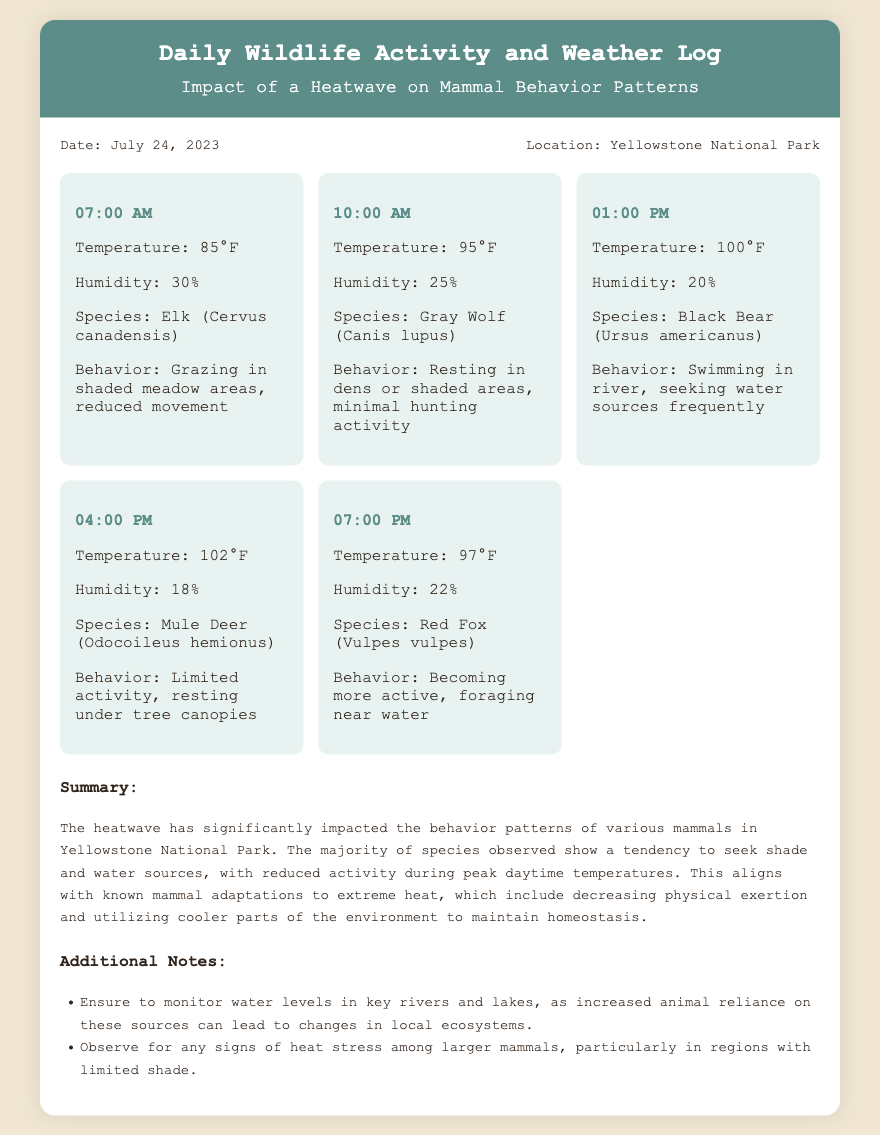what is the date of the log? The date is mentioned in the info section of the document as July 24, 2023.
Answer: July 24, 2023 what is the location of the observations? The location is stated in the info section as Yellowstone National Park.
Answer: Yellowstone National Park what species was observed at 01:00 PM? The species observed at that time is detailed in the observations section of the document as Black Bear.
Answer: Black Bear what behavior did the Gray Wolf exhibit at 10:00 AM? The behavior is described in the observations as resting in dens or shaded areas, minimal hunting activity.
Answer: Resting in dens or shaded areas how did the heatwave impact mammal activity according to the summary? The summary indicates that mammals tend to seek shade and water sources with reduced activity during peak temperatures.
Answer: Seek shade and water sources what temperature was recorded at 04:00 PM? The temperature is stated in the observations section as 102°F.
Answer: 102°F what is one additional note provided in the document? The notes section includes various points; one is to monitor water levels in key rivers and lakes.
Answer: Monitor water levels in key rivers and lakes what behavior did the Red Fox show at 07:00 PM? The behavior is detailed in the observations as becoming more active, foraging near water.
Answer: Becoming more active, foraging near water what is the humidity percentage recorded at 07:00 PM? The humidity percentage is shown in the observations for that time as 22%.
Answer: 22% 